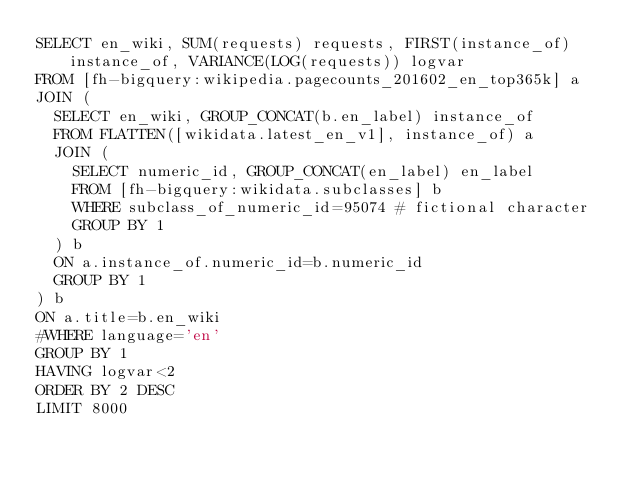<code> <loc_0><loc_0><loc_500><loc_500><_SQL_>SELECT en_wiki, SUM(requests) requests, FIRST(instance_of) instance_of, VARIANCE(LOG(requests)) logvar
FROM [fh-bigquery:wikipedia.pagecounts_201602_en_top365k] a 
JOIN (
  SELECT en_wiki, GROUP_CONCAT(b.en_label) instance_of
  FROM FLATTEN([wikidata.latest_en_v1], instance_of) a
  JOIN (
    SELECT numeric_id, GROUP_CONCAT(en_label) en_label
    FROM [fh-bigquery:wikidata.subclasses] b
    WHERE subclass_of_numeric_id=95074 # fictional character
    GROUP BY 1
  ) b
  ON a.instance_of.numeric_id=b.numeric_id
  GROUP BY 1
) b
ON a.title=b.en_wiki
#WHERE language='en'
GROUP BY 1
HAVING logvar<2
ORDER BY 2 DESC
LIMIT 8000

</code> 